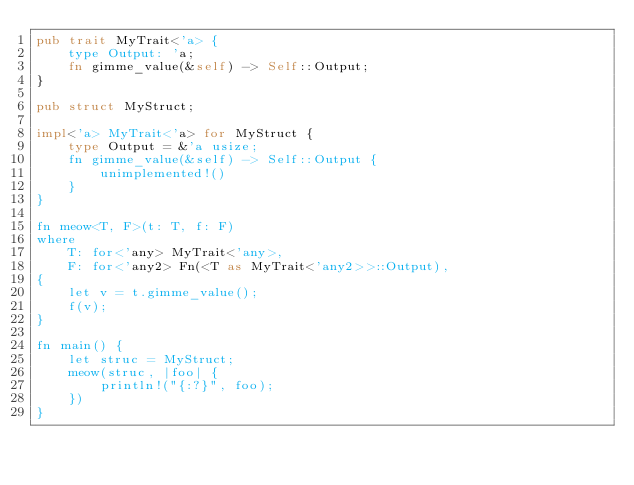<code> <loc_0><loc_0><loc_500><loc_500><_Rust_>pub trait MyTrait<'a> {
    type Output: 'a;
    fn gimme_value(&self) -> Self::Output;
}

pub struct MyStruct;

impl<'a> MyTrait<'a> for MyStruct {
    type Output = &'a usize;
    fn gimme_value(&self) -> Self::Output {
        unimplemented!()
    }
}

fn meow<T, F>(t: T, f: F)
where
    T: for<'any> MyTrait<'any>,
    F: for<'any2> Fn(<T as MyTrait<'any2>>::Output),
{
    let v = t.gimme_value();
    f(v);
}

fn main() {
    let struc = MyStruct;
    meow(struc, |foo| {
        println!("{:?}", foo);
    })
}
</code> 